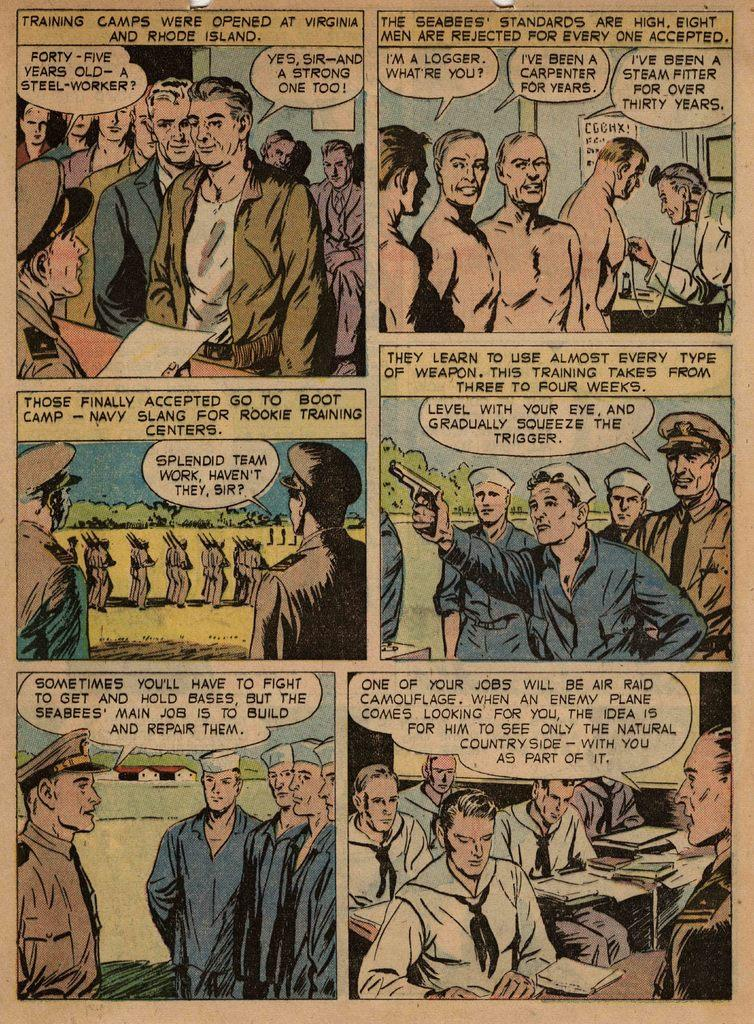<image>
Present a compact description of the photo's key features. A color comic detailing when Training camps were opened at Virginia and Rhode Island. 